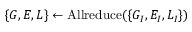Convert formula to latex. <formula><loc_0><loc_0><loc_500><loc_500>\{ G , E , L \} \leftarrow A l l r e d u c e ( \{ G _ { I } , E _ { I } , L _ { I } \} )</formula> 